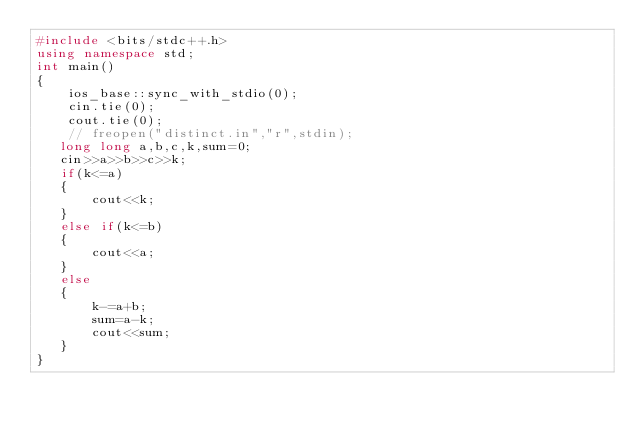Convert code to text. <code><loc_0><loc_0><loc_500><loc_500><_C++_>#include <bits/stdc++.h>
using namespace std;
int main()
{
    ios_base::sync_with_stdio(0);
    cin.tie(0);
    cout.tie(0);
    // freopen("distinct.in","r",stdin);
   long long a,b,c,k,sum=0;
   cin>>a>>b>>c>>k;
   if(k<=a)
   {
       cout<<k;
   }
   else if(k<=b)
   {
       cout<<a;
   }
   else
   {
       k-=a+b;
       sum=a-k;
       cout<<sum;
   }
}
</code> 